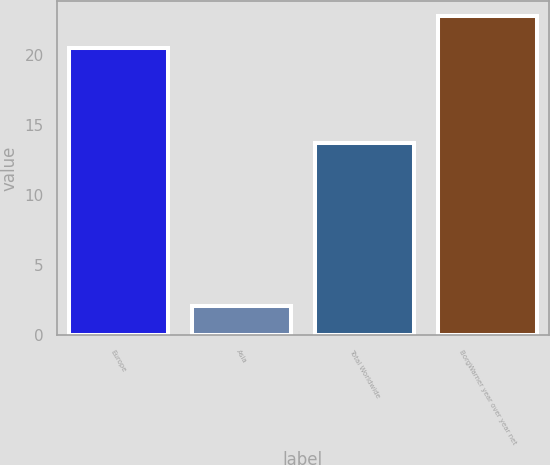Convert chart to OTSL. <chart><loc_0><loc_0><loc_500><loc_500><bar_chart><fcel>Europe<fcel>Asia<fcel>Total Worldwide<fcel>BorgWarner year over year net<nl><fcel>20.5<fcel>2.1<fcel>13.7<fcel>22.76<nl></chart> 